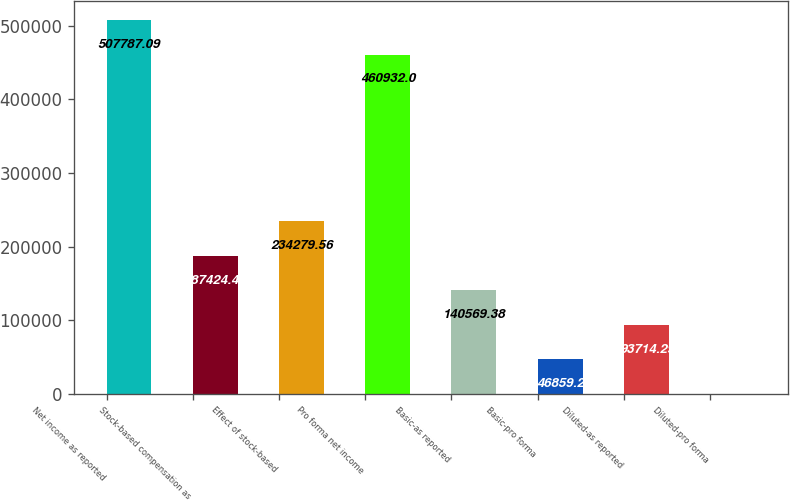Convert chart to OTSL. <chart><loc_0><loc_0><loc_500><loc_500><bar_chart><fcel>Net income as reported<fcel>Stock-based compensation as<fcel>Effect of stock-based<fcel>Pro forma net income<fcel>Basic-as reported<fcel>Basic-pro forma<fcel>Diluted-as reported<fcel>Diluted-pro forma<nl><fcel>507787<fcel>187424<fcel>234280<fcel>460932<fcel>140569<fcel>46859.2<fcel>93714.3<fcel>4.11<nl></chart> 